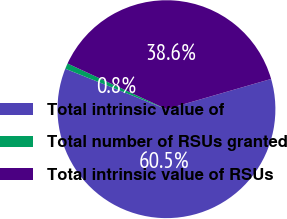Convert chart to OTSL. <chart><loc_0><loc_0><loc_500><loc_500><pie_chart><fcel>Total intrinsic value of<fcel>Total number of RSUs granted<fcel>Total intrinsic value of RSUs<nl><fcel>60.53%<fcel>0.83%<fcel>38.64%<nl></chart> 